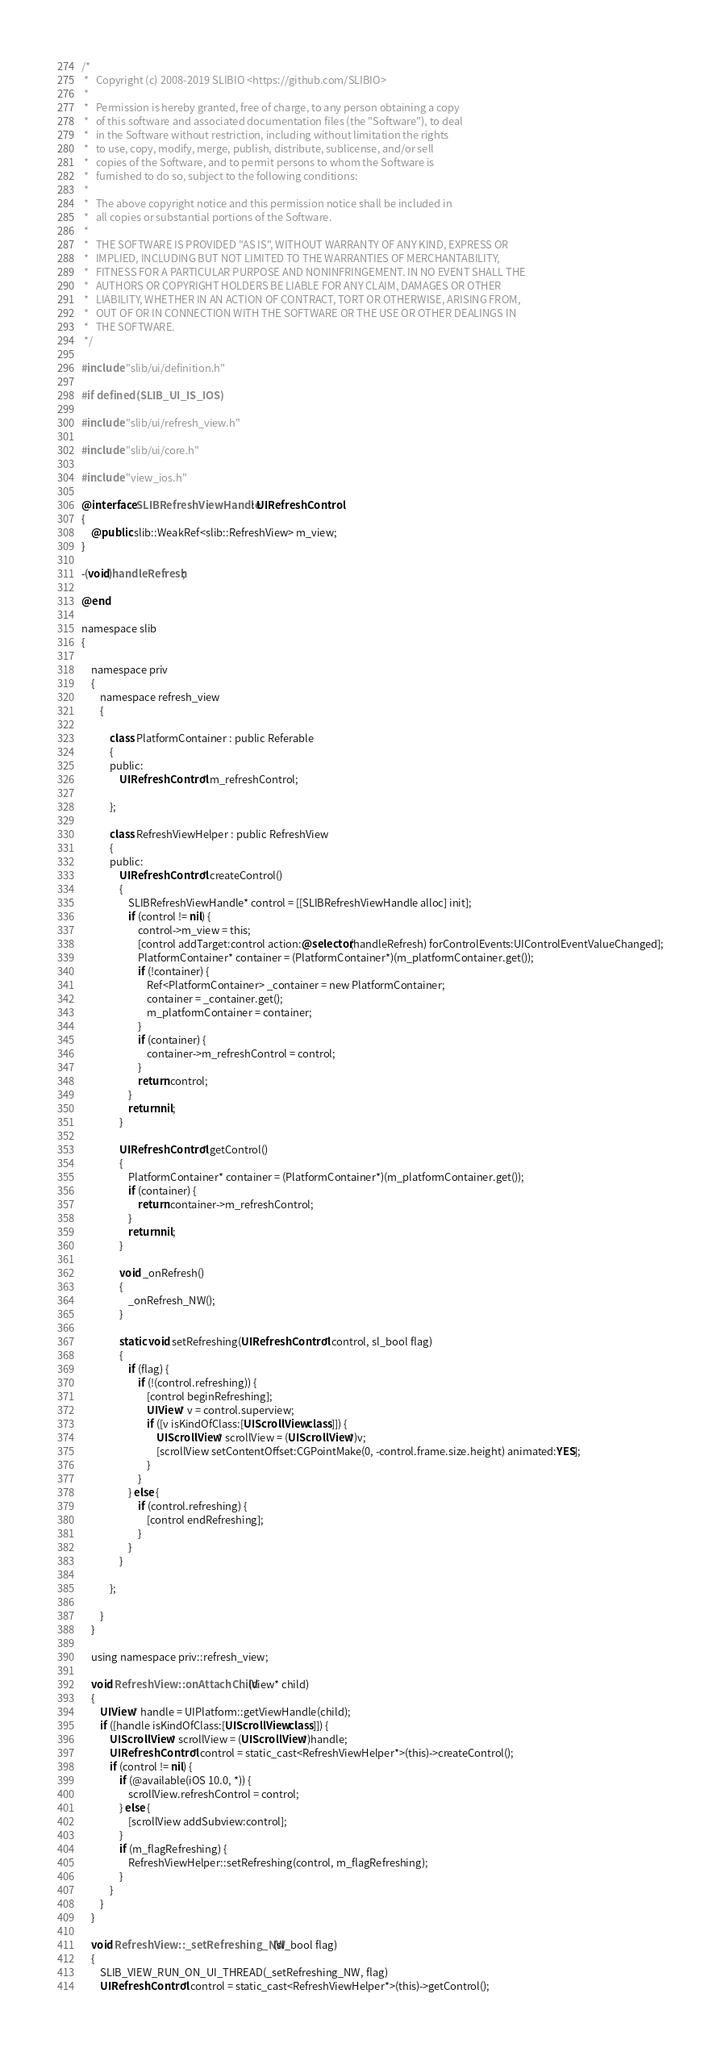<code> <loc_0><loc_0><loc_500><loc_500><_ObjectiveC_>/*
 *   Copyright (c) 2008-2019 SLIBIO <https://github.com/SLIBIO>
 *
 *   Permission is hereby granted, free of charge, to any person obtaining a copy
 *   of this software and associated documentation files (the "Software"), to deal
 *   in the Software without restriction, including without limitation the rights
 *   to use, copy, modify, merge, publish, distribute, sublicense, and/or sell
 *   copies of the Software, and to permit persons to whom the Software is
 *   furnished to do so, subject to the following conditions:
 *
 *   The above copyright notice and this permission notice shall be included in
 *   all copies or substantial portions of the Software.
 *
 *   THE SOFTWARE IS PROVIDED "AS IS", WITHOUT WARRANTY OF ANY KIND, EXPRESS OR
 *   IMPLIED, INCLUDING BUT NOT LIMITED TO THE WARRANTIES OF MERCHANTABILITY,
 *   FITNESS FOR A PARTICULAR PURPOSE AND NONINFRINGEMENT. IN NO EVENT SHALL THE
 *   AUTHORS OR COPYRIGHT HOLDERS BE LIABLE FOR ANY CLAIM, DAMAGES OR OTHER
 *   LIABILITY, WHETHER IN AN ACTION OF CONTRACT, TORT OR OTHERWISE, ARISING FROM,
 *   OUT OF OR IN CONNECTION WITH THE SOFTWARE OR THE USE OR OTHER DEALINGS IN
 *   THE SOFTWARE.
 */

#include "slib/ui/definition.h"

#if defined(SLIB_UI_IS_IOS)

#include "slib/ui/refresh_view.h"

#include "slib/ui/core.h"

#include "view_ios.h"

@interface SLIBRefreshViewHandle: UIRefreshControl
{
	@public slib::WeakRef<slib::RefreshView> m_view;
}

-(void)handleRefresh;

@end

namespace slib
{
	
	namespace priv
	{
		namespace refresh_view
		{

			class PlatformContainer : public Referable
			{
			public:
				UIRefreshControl* m_refreshControl;
				
			};
			
			class RefreshViewHelper : public RefreshView
			{
			public:
				UIRefreshControl* createControl()
				{
					SLIBRefreshViewHandle* control = [[SLIBRefreshViewHandle alloc] init];
					if (control != nil) {
						control->m_view = this;
						[control addTarget:control action:@selector(handleRefresh) forControlEvents:UIControlEventValueChanged];
						PlatformContainer* container = (PlatformContainer*)(m_platformContainer.get());
						if (!container) {
							Ref<PlatformContainer> _container = new PlatformContainer;
							container = _container.get();
							m_platformContainer = container;
						}
						if (container) {
							container->m_refreshControl = control;
						}
						return control;
					}
					return nil;
				}
				
				UIRefreshControl* getControl()
				{
					PlatformContainer* container = (PlatformContainer*)(m_platformContainer.get());
					if (container) {
						return container->m_refreshControl;
					}
					return nil;
				}
				
				void _onRefresh()
				{
					_onRefresh_NW();
				}
				
				static void setRefreshing(UIRefreshControl* control, sl_bool flag)
				{
					if (flag) {
						if (!(control.refreshing)) {
							[control beginRefreshing];
							UIView* v = control.superview;
							if ([v isKindOfClass:[UIScrollView class]]) {
								UIScrollView* scrollView = (UIScrollView*)v;
								[scrollView setContentOffset:CGPointMake(0, -control.frame.size.height) animated:YES];
							}
						}
					} else {
						if (control.refreshing) {
							[control endRefreshing];
						}
					}
				}
				
			};
		
		}
	}

	using namespace priv::refresh_view;

	void RefreshView::onAttachChild(View* child)
	{
		UIView* handle = UIPlatform::getViewHandle(child);
		if ([handle isKindOfClass:[UIScrollView class]]) {
			UIScrollView* scrollView = (UIScrollView*)handle;
			UIRefreshControl* control = static_cast<RefreshViewHelper*>(this)->createControl();
			if (control != nil) {
				if (@available(iOS 10.0, *)) {
					scrollView.refreshControl = control;
				} else {
					[scrollView addSubview:control];
				}
				if (m_flagRefreshing) {
					RefreshViewHelper::setRefreshing(control, m_flagRefreshing);
				}
			}
		}
	}
	
	void RefreshView::_setRefreshing_NW(sl_bool flag)
	{
		SLIB_VIEW_RUN_ON_UI_THREAD(_setRefreshing_NW, flag)
		UIRefreshControl* control = static_cast<RefreshViewHelper*>(this)->getControl();</code> 